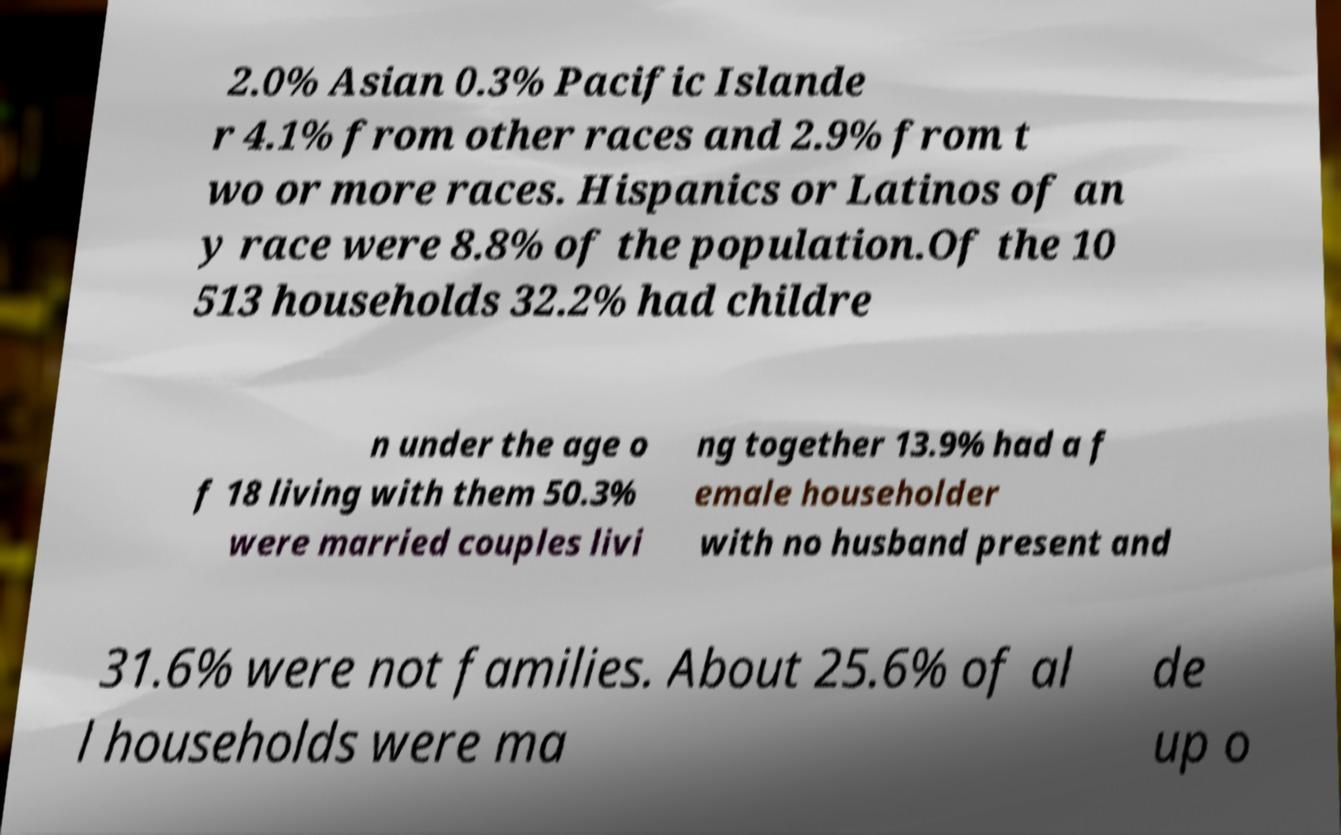Please identify and transcribe the text found in this image. 2.0% Asian 0.3% Pacific Islande r 4.1% from other races and 2.9% from t wo or more races. Hispanics or Latinos of an y race were 8.8% of the population.Of the 10 513 households 32.2% had childre n under the age o f 18 living with them 50.3% were married couples livi ng together 13.9% had a f emale householder with no husband present and 31.6% were not families. About 25.6% of al l households were ma de up o 